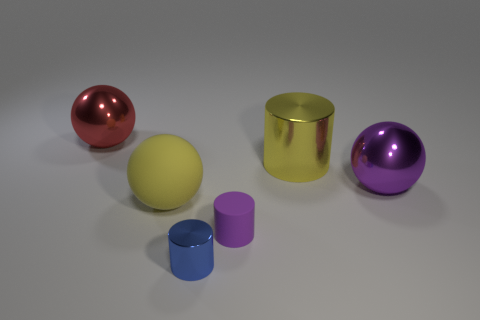Subtract all big yellow rubber balls. How many balls are left? 2 Add 4 red rubber objects. How many objects exist? 10 Add 1 blue shiny objects. How many blue shiny objects are left? 2 Add 5 small green metallic objects. How many small green metallic objects exist? 5 Subtract 0 cyan cylinders. How many objects are left? 6 Subtract all large yellow cylinders. Subtract all big things. How many objects are left? 1 